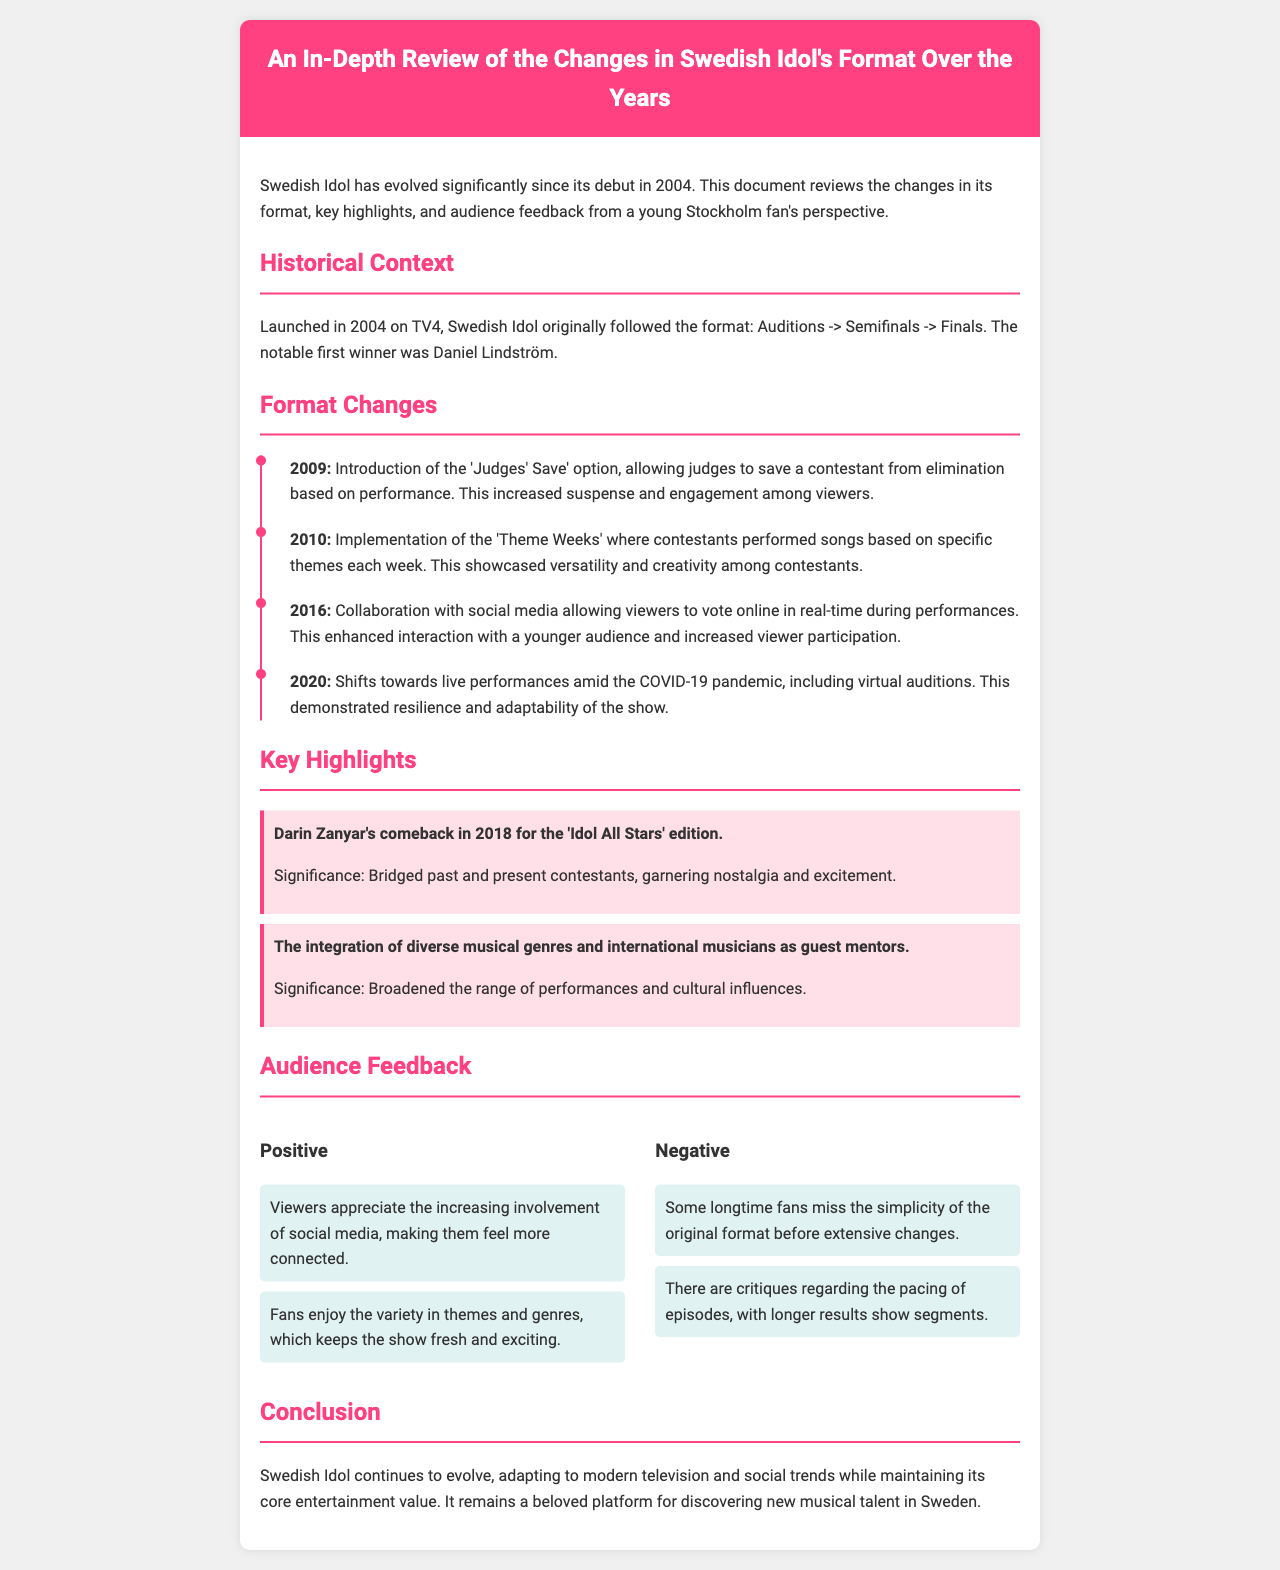What year did Swedish Idol first air? The document states that Swedish Idol was launched in 2004 on TV4.
Answer: 2004 Who was the notable first winner of Swedish Idol? According to the report, the first winner was Daniel Lindström.
Answer: Daniel Lindström What significant change was introduced in 2009? The document mentions the 'Judges' Save' option was introduced in 2009, allowing judges to save a contestant from elimination.
Answer: Judges' Save What was implemented in 2010 to showcase contestants' versatility? The report specifies that 'Theme Weeks' were implemented in 2010, where contestants performed songs based on specific themes.
Answer: Theme Weeks What was a major adaptation made in 2020 due to COVID-19? The document notes that there was a shift towards live performances and virtual auditions during the COVID-19 pandemic in 2020.
Answer: Live performances Which contestant made a comeback in 2018 for 'Idol All Stars'? According to the highlights, Darin Zanyar made a comeback in 2018.
Answer: Darin Zanyar What do viewers appreciate about the involvement of social media? The document states that viewers appreciate the increasing involvement of social media, making them feel more connected.
Answer: Connected What criticism do some longtime fans have regarding the format? The report mentions that some longtime fans miss the simplicity of the original format before extensive changes.
Answer: Simplicity What does the audience enjoy about the variety in themes and genres? The audience enjoys the variety in themes and genres, which keeps the show fresh and exciting according to the feedback section.
Answer: Fresh and exciting 